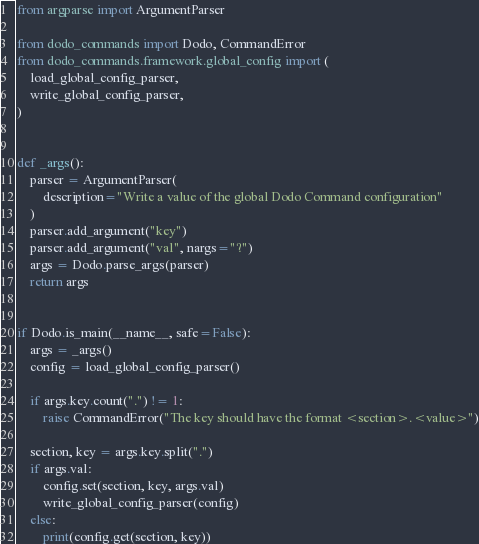<code> <loc_0><loc_0><loc_500><loc_500><_Python_>from argparse import ArgumentParser

from dodo_commands import Dodo, CommandError
from dodo_commands.framework.global_config import (
    load_global_config_parser,
    write_global_config_parser,
)


def _args():
    parser = ArgumentParser(
        description="Write a value of the global Dodo Command configuration"
    )
    parser.add_argument("key")
    parser.add_argument("val", nargs="?")
    args = Dodo.parse_args(parser)
    return args


if Dodo.is_main(__name__, safe=False):
    args = _args()
    config = load_global_config_parser()

    if args.key.count(".") != 1:
        raise CommandError("The key should have the format <section>.<value>")

    section, key = args.key.split(".")
    if args.val:
        config.set(section, key, args.val)
        write_global_config_parser(config)
    else:
        print(config.get(section, key))
</code> 